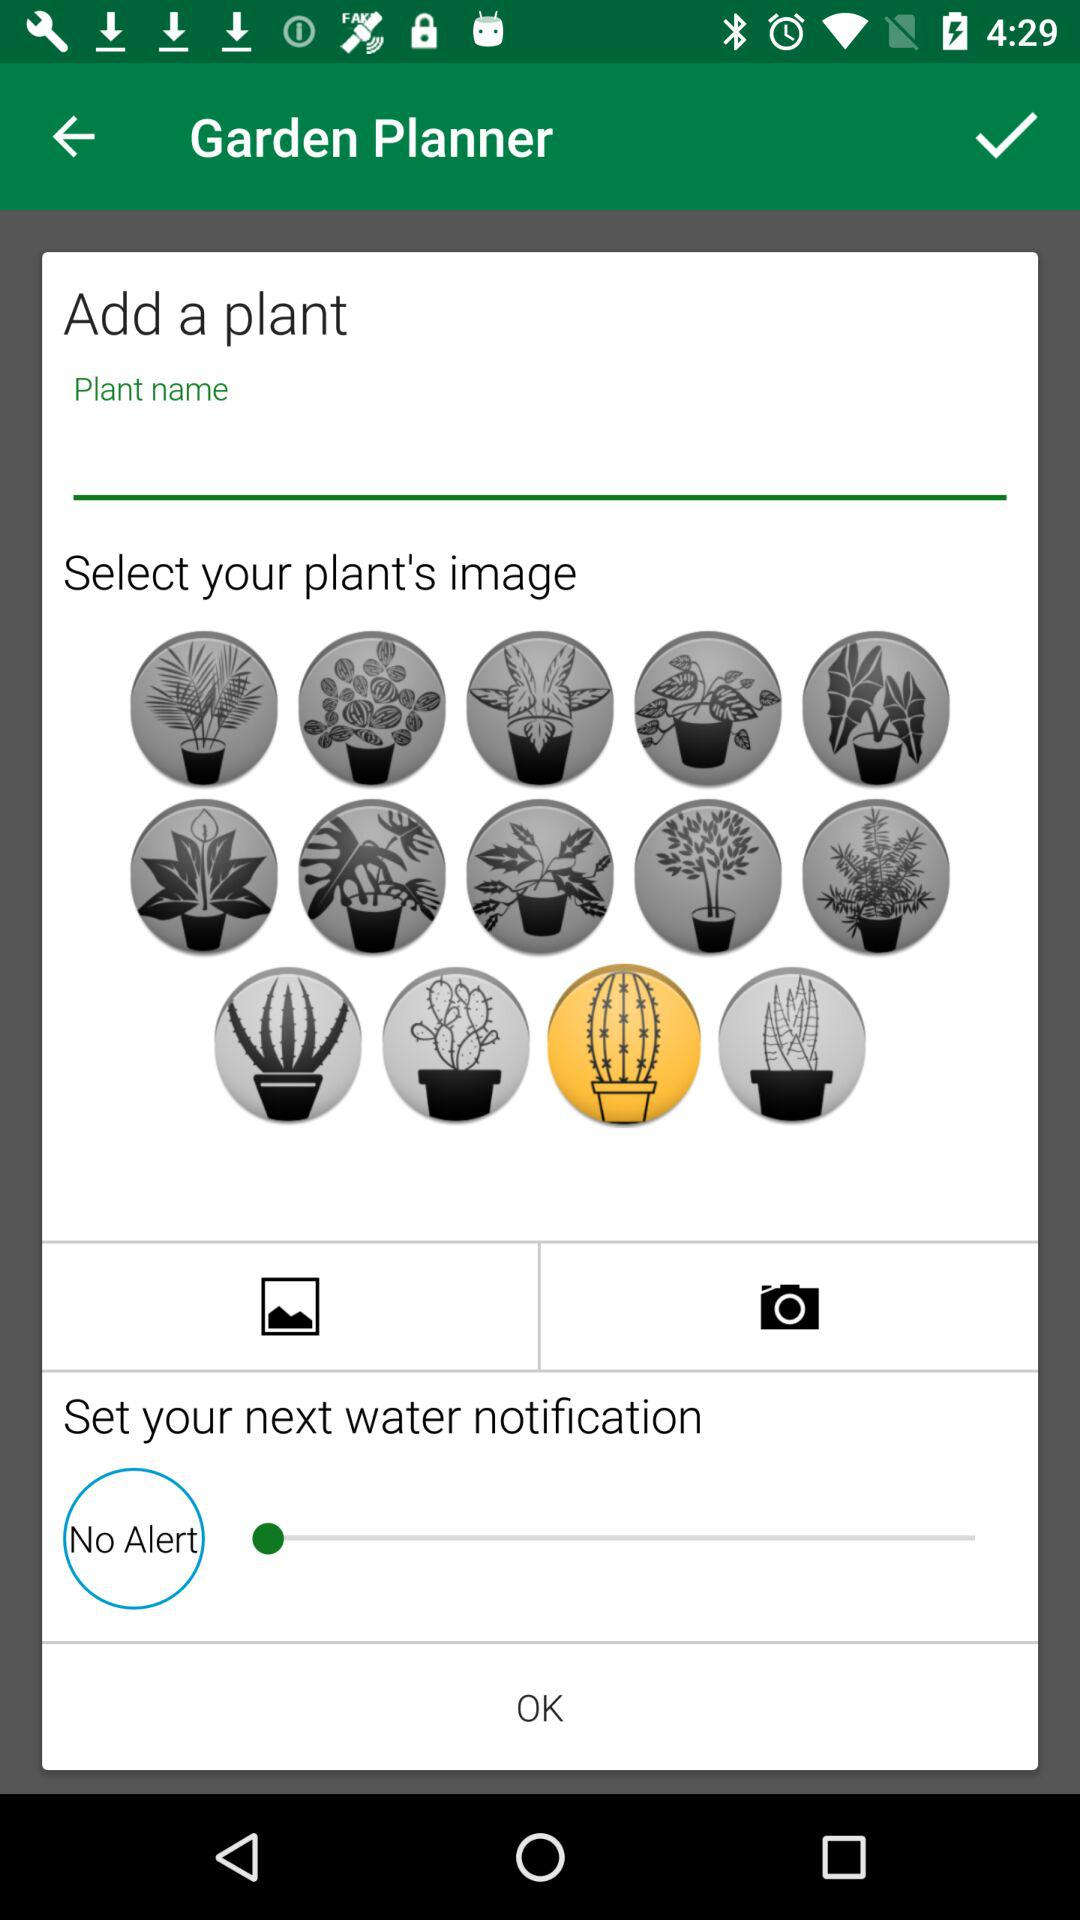What is the status of water notification?
When the provided information is insufficient, respond with <no answer>. <no answer> 